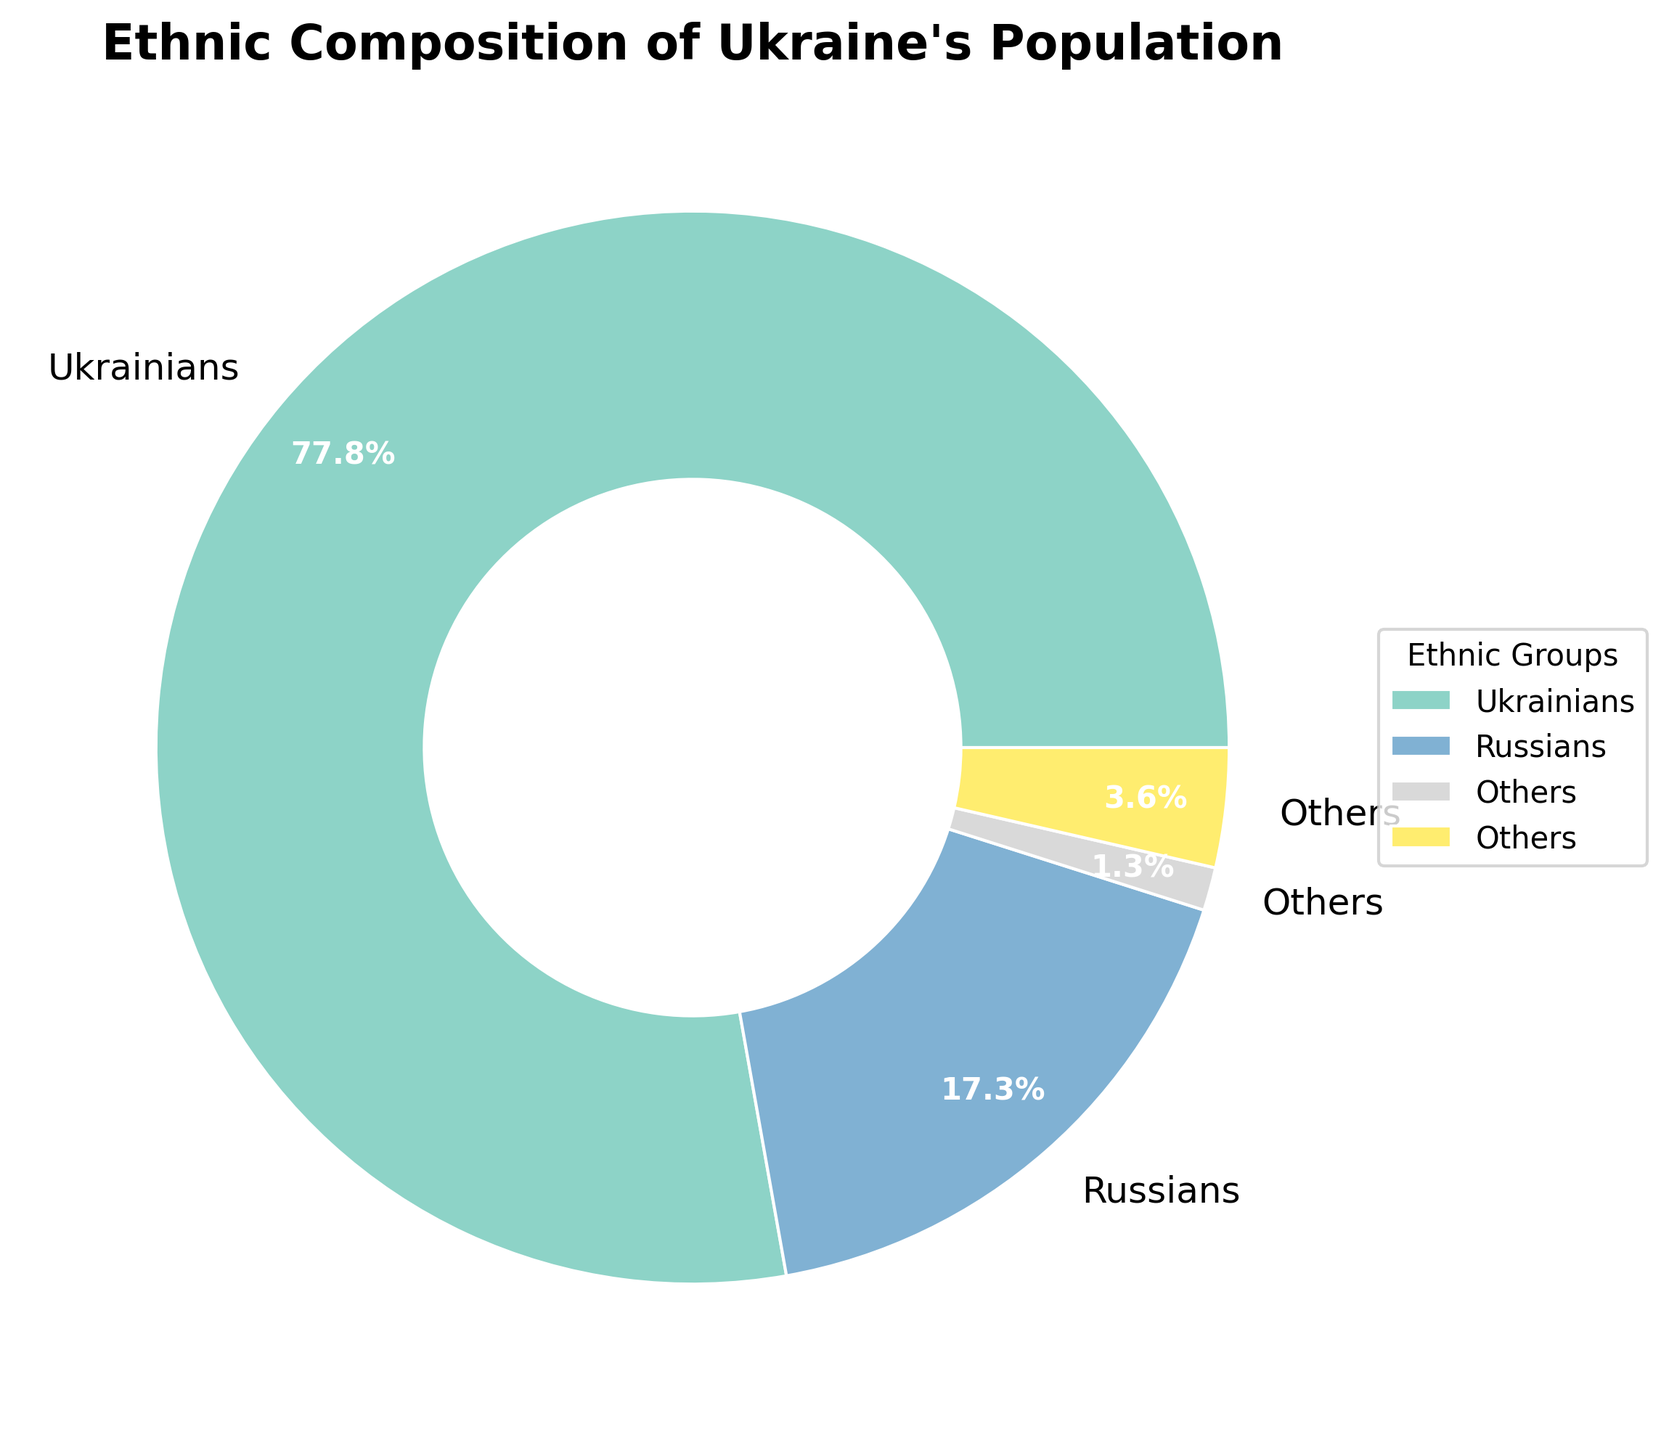Which ethnic group constitutes the largest portion of Ukraine's population? The pie chart shows the largest portion marked in one of the distinct segments. The label associated with the largest segment reads '77.8%' attributed to 'Ukrainians'.
Answer: Ukrainians What is the combined percentage of the population for Belarusians and Moldovans? The chart displays individual segments for each ethnic group including Belarusians (0.6%) and Moldovans (0.5%). Adding these gives 0.6% + 0.5%.
Answer: 1.1% Which ethnic groups have exactly the same percentage representation in Ukraine's population based on the chart? The chart shows specific percentage values for each ethnic group. Both Crimean Tatars and Moldovans are labeled with 0.5%, and similarly, a few other groups like Hungarians, Romanians, and Poles with 0.3% each.
Answer: Crimean Tatars and Moldovans; Hungarians, Romanians, and Poles What is the percentage of the 'Others' category in the pie chart? The pie chart sums the portions of the groups with less than 1% into an 'Others' category. The corresponding segment for 'Others' is labeled. Adding all the smaller segments gives '1.3%'.
Answer: 1.3% How does the Russian population percentage compare to the sum of all other non-Ukrainian ethnic groups? The important segments to compare are Russians (17.3%) vs. the combined sum of all minor groups including 'Others'. Calculating this sum involves adding all non-Ukrainian segments excluding 'Russians', which yields 17.3% < 22.7%.
Answer: The Russian percentage (17.3%) is less than the combined total for all remaining non-Ukrainian groups (22.7%) What is the difference between the percentage of Ukrainians and Russians in the population? The segments for Ukrainians (77.8%) and Russians (17.3%) show their respective percentages. Subtracting these values gives 77.8% - 17.3%.
Answer: 60.5% Which ethnic group segment is marked in the lightest color? Observing the pie chart for the distribution of colors, the segment for 'Others' appears to be in the lightest shade of the palette.
Answer: Others What is the total percentage of ethnic minorities (excluding Ukrainians and Russians)? The chart lists percentages for each segment, so to find all other minorities, sum the values of Belarusians, Moldovans, Crimean Tatars, Bulgarians, Hungarians, Romanians, Poles, Jews, Armenians, Greeks, Roma, and 'Others': 0.6% + 0.5% + 0.5% + 0.4% + 0.3% + 0.3% + 0.3% + 0.2% + 0.2% + 0.2% + 0.1% + 1.3%. The result is 4.5%.
Answer: 4.5% What color is used for the 'Ukrainians' segment in the pie chart? Reviewing the pie chart, 'Ukrainians' are represented by the most distinct and predominant color segment in the diagram.
Answer: Largest distinct segment color 